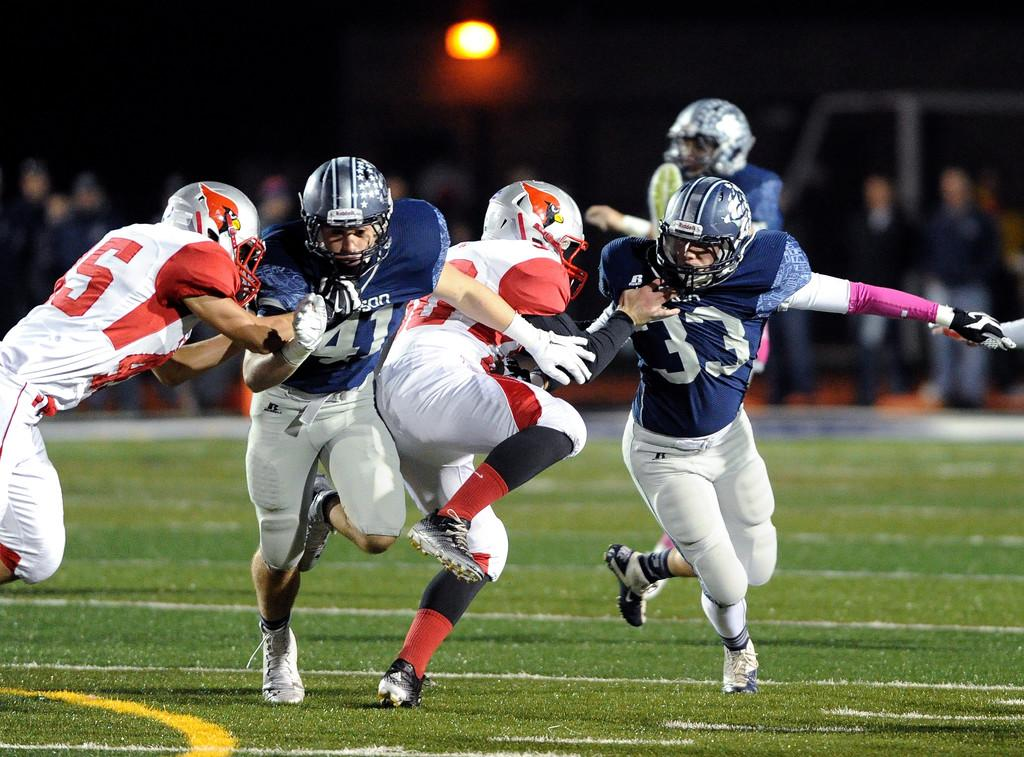What are the persons in the image doing? The persons in the image are playing. Can you describe the background of the image? The background of the image is blurry. What type of surface is visible on the ground in the image? There is grass on the ground in the image. What color is the ocean in the image? There is no ocean present in the image. 